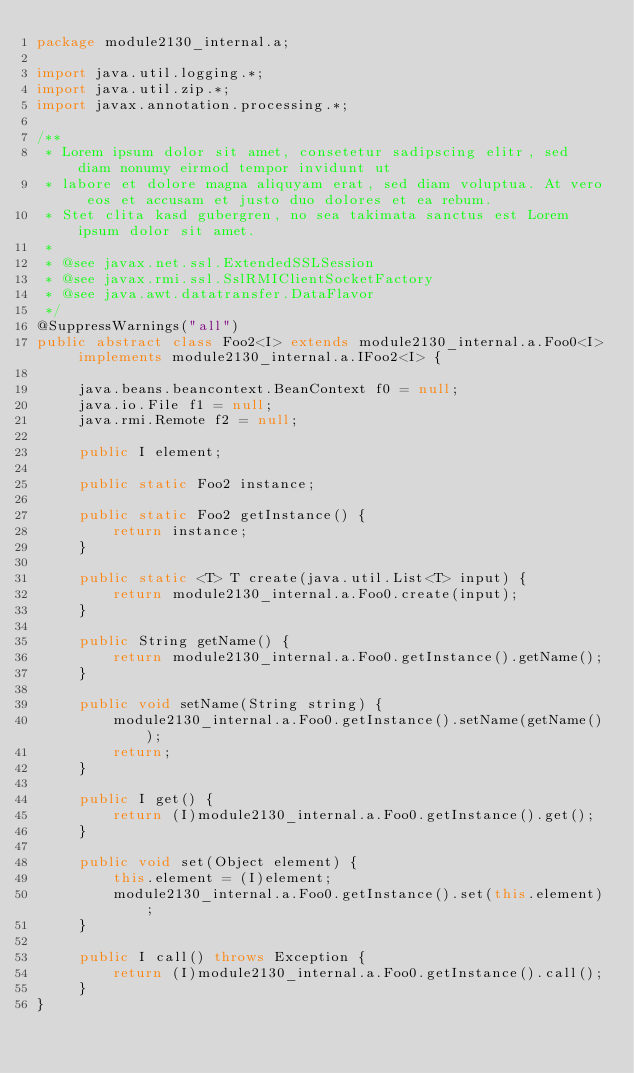Convert code to text. <code><loc_0><loc_0><loc_500><loc_500><_Java_>package module2130_internal.a;

import java.util.logging.*;
import java.util.zip.*;
import javax.annotation.processing.*;

/**
 * Lorem ipsum dolor sit amet, consetetur sadipscing elitr, sed diam nonumy eirmod tempor invidunt ut 
 * labore et dolore magna aliquyam erat, sed diam voluptua. At vero eos et accusam et justo duo dolores et ea rebum. 
 * Stet clita kasd gubergren, no sea takimata sanctus est Lorem ipsum dolor sit amet. 
 *
 * @see javax.net.ssl.ExtendedSSLSession
 * @see javax.rmi.ssl.SslRMIClientSocketFactory
 * @see java.awt.datatransfer.DataFlavor
 */
@SuppressWarnings("all")
public abstract class Foo2<I> extends module2130_internal.a.Foo0<I> implements module2130_internal.a.IFoo2<I> {

	 java.beans.beancontext.BeanContext f0 = null;
	 java.io.File f1 = null;
	 java.rmi.Remote f2 = null;

	 public I element;

	 public static Foo2 instance;

	 public static Foo2 getInstance() {
	 	 return instance;
	 }

	 public static <T> T create(java.util.List<T> input) {
	 	 return module2130_internal.a.Foo0.create(input);
	 }

	 public String getName() {
	 	 return module2130_internal.a.Foo0.getInstance().getName();
	 }

	 public void setName(String string) {
	 	 module2130_internal.a.Foo0.getInstance().setName(getName());
	 	 return;
	 }

	 public I get() {
	 	 return (I)module2130_internal.a.Foo0.getInstance().get();
	 }

	 public void set(Object element) {
	 	 this.element = (I)element;
	 	 module2130_internal.a.Foo0.getInstance().set(this.element);
	 }

	 public I call() throws Exception {
	 	 return (I)module2130_internal.a.Foo0.getInstance().call();
	 }
}
</code> 